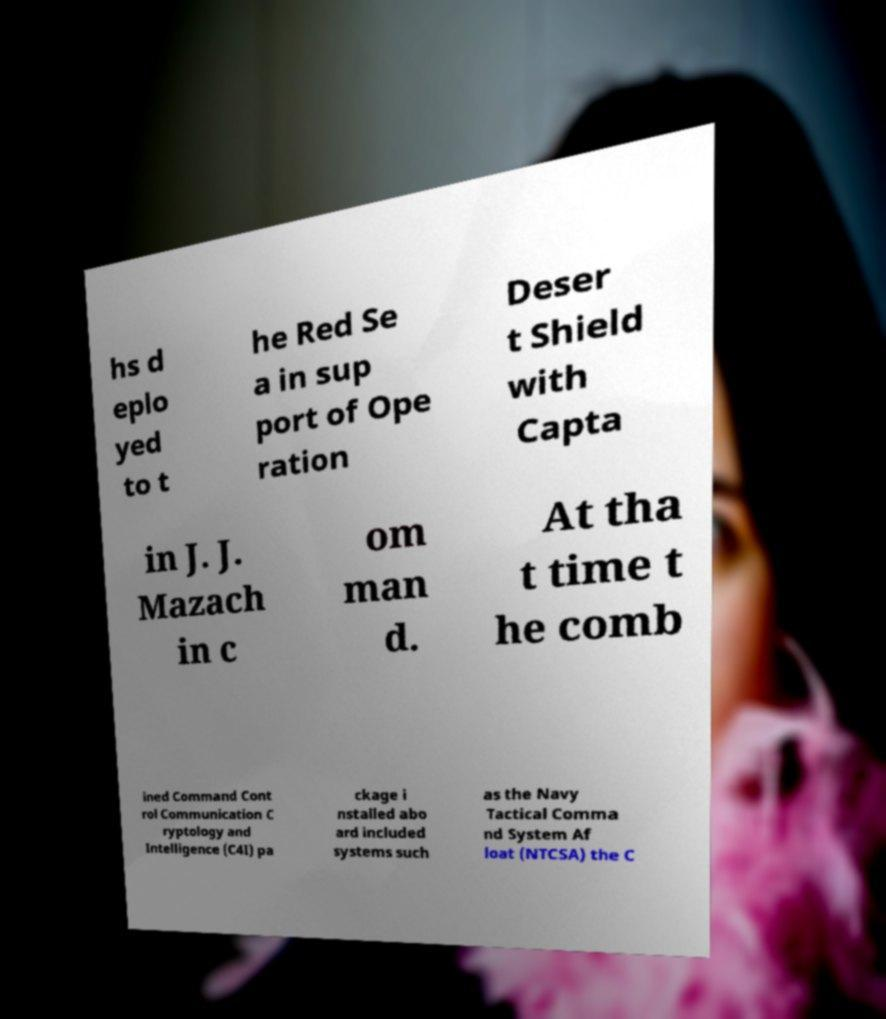Can you accurately transcribe the text from the provided image for me? hs d eplo yed to t he Red Se a in sup port of Ope ration Deser t Shield with Capta in J. J. Mazach in c om man d. At tha t time t he comb ined Command Cont rol Communication C ryptology and Intelligence (C4I) pa ckage i nstalled abo ard included systems such as the Navy Tactical Comma nd System Af loat (NTCSA) the C 